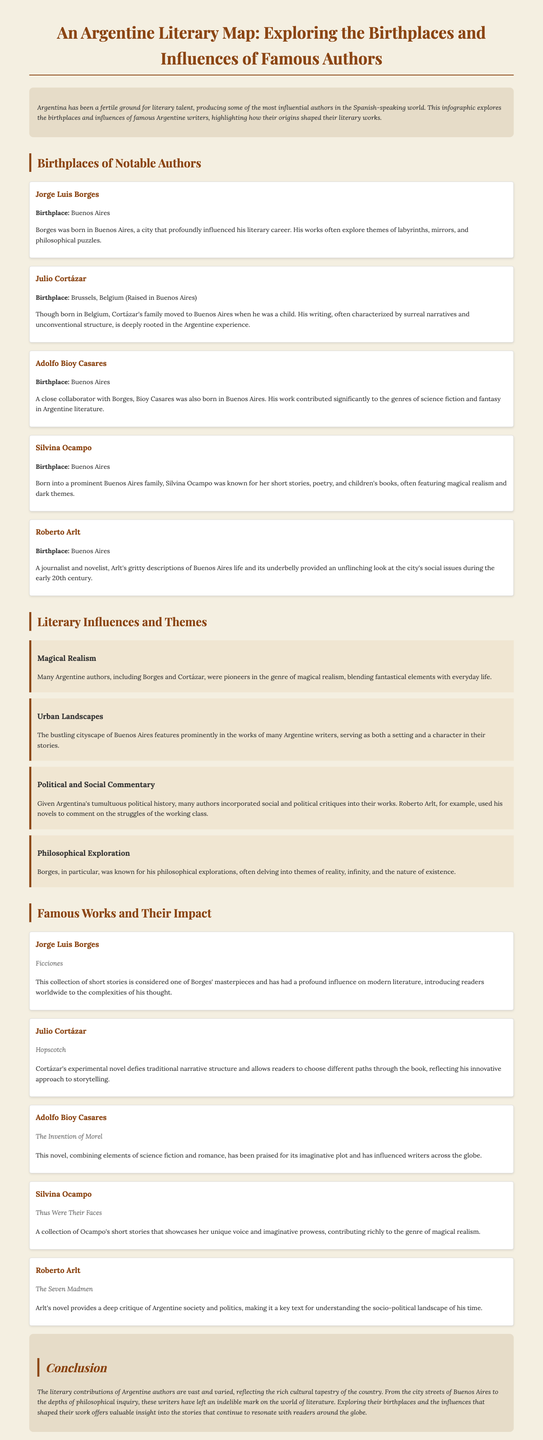what is the birthplace of Jorge Luis Borges? The document mentions Buenos Aires as the birthplace of Jorge Luis Borges.
Answer: Buenos Aires who is known for the surreal narratives and unconventional structure? The document describes Julio Cortázar's writing as characterized by surreal narratives and unconventional structure.
Answer: Julio Cortázar what genre did Adolfo Bioy Casares significantly contribute to? The document states that Adolfo Bioy Casares contributed significantly to the genres of science fiction and fantasy.
Answer: Science fiction and fantasy which author is associated with the theme of philosophical exploration? The document specifically mentions Borges as known for his philosophical explorations.
Answer: Borges what is the title of Julio Cortázar's experimental novel? The document cites "Hopscotch" as the title of Julio Cortázar's experimental novel.
Answer: Hopscotch how many notable authors are listed in the "Birthplaces of Notable Authors" section? There are five authors listed in the "Birthplaces of Notable Authors" section of the document.
Answer: Five in which year does the author indicate a significant literary contribution from Argentine writers began? The introductory section does not specify a year, but it suggests that Argentine authors have contributed significantly to literature throughout history.
Answer: Not specified what literary theme involves blending fantastical elements with everyday life? The document describes magical realism as blending fantastical elements with everyday life.
Answer: Magical realism who wrote the collection of short stories titled "Thus Were Their Faces"? The document attributes "Thus Were Their Faces" to Silvina Ocampo.
Answer: Silvina Ocampo 